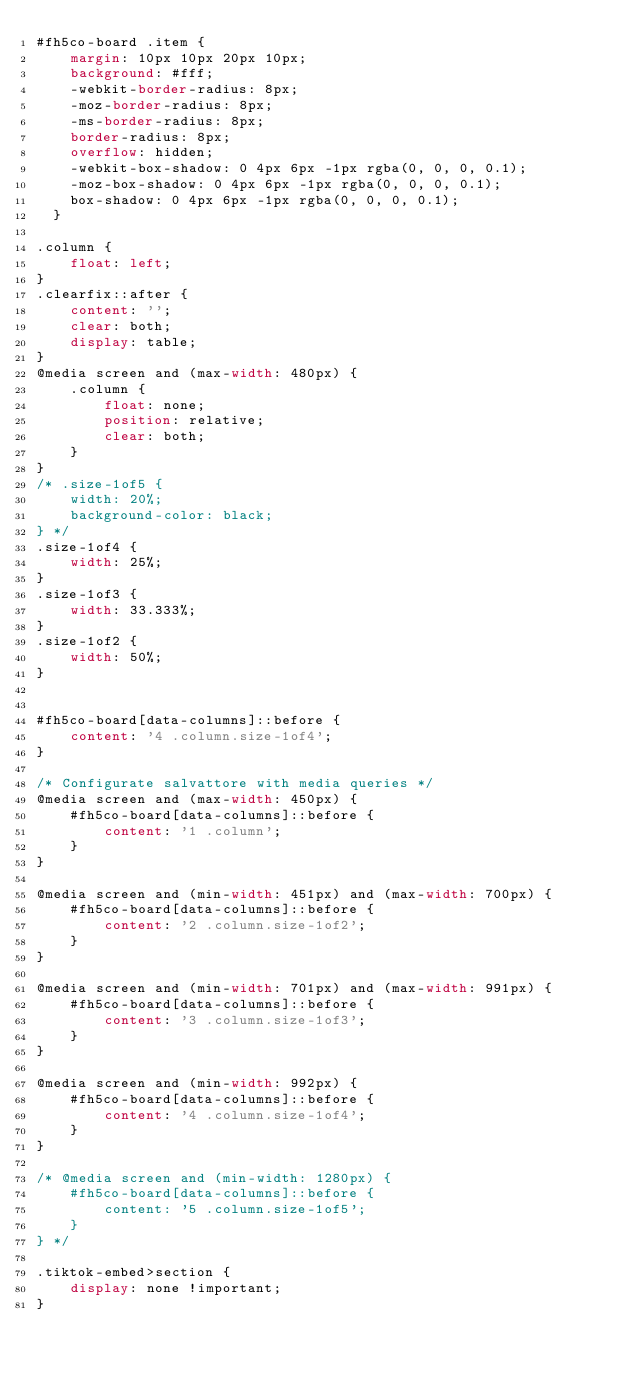<code> <loc_0><loc_0><loc_500><loc_500><_CSS_>#fh5co-board .item {
    margin: 10px 10px 20px 10px;
    background: #fff;
    -webkit-border-radius: 8px;
    -moz-border-radius: 8px;
    -ms-border-radius: 8px;
    border-radius: 8px;
    overflow: hidden;
    -webkit-box-shadow: 0 4px 6px -1px rgba(0, 0, 0, 0.1);
    -moz-box-shadow: 0 4px 6px -1px rgba(0, 0, 0, 0.1);
    box-shadow: 0 4px 6px -1px rgba(0, 0, 0, 0.1);
  }

.column {
    float: left;
}
.clearfix::after {
    content: '';
    clear: both;
    display: table;
}
@media screen and (max-width: 480px) {
    .column {
        float: none;
        position: relative;
        clear: both;
    }
}
/* .size-1of5 {
    width: 20%;
    background-color: black;
} */
.size-1of4 {
    width: 25%;
}
.size-1of3 {
    width: 33.333%;
}
.size-1of2 {
    width: 50%;
}


#fh5co-board[data-columns]::before {
    content: '4 .column.size-1of4';
}

/* Configurate salvattore with media queries */
@media screen and (max-width: 450px) {
    #fh5co-board[data-columns]::before {
        content: '1 .column';
    }
}

@media screen and (min-width: 451px) and (max-width: 700px) {
    #fh5co-board[data-columns]::before {
        content: '2 .column.size-1of2';
    }
}

@media screen and (min-width: 701px) and (max-width: 991px) {
    #fh5co-board[data-columns]::before {
        content: '3 .column.size-1of3';
    }
}

@media screen and (min-width: 992px) {
    #fh5co-board[data-columns]::before {
        content: '4 .column.size-1of4';
    }
}

/* @media screen and (min-width: 1280px) {
    #fh5co-board[data-columns]::before {
        content: '5 .column.size-1of5';
    }
} */

.tiktok-embed>section {
    display: none !important;
}</code> 